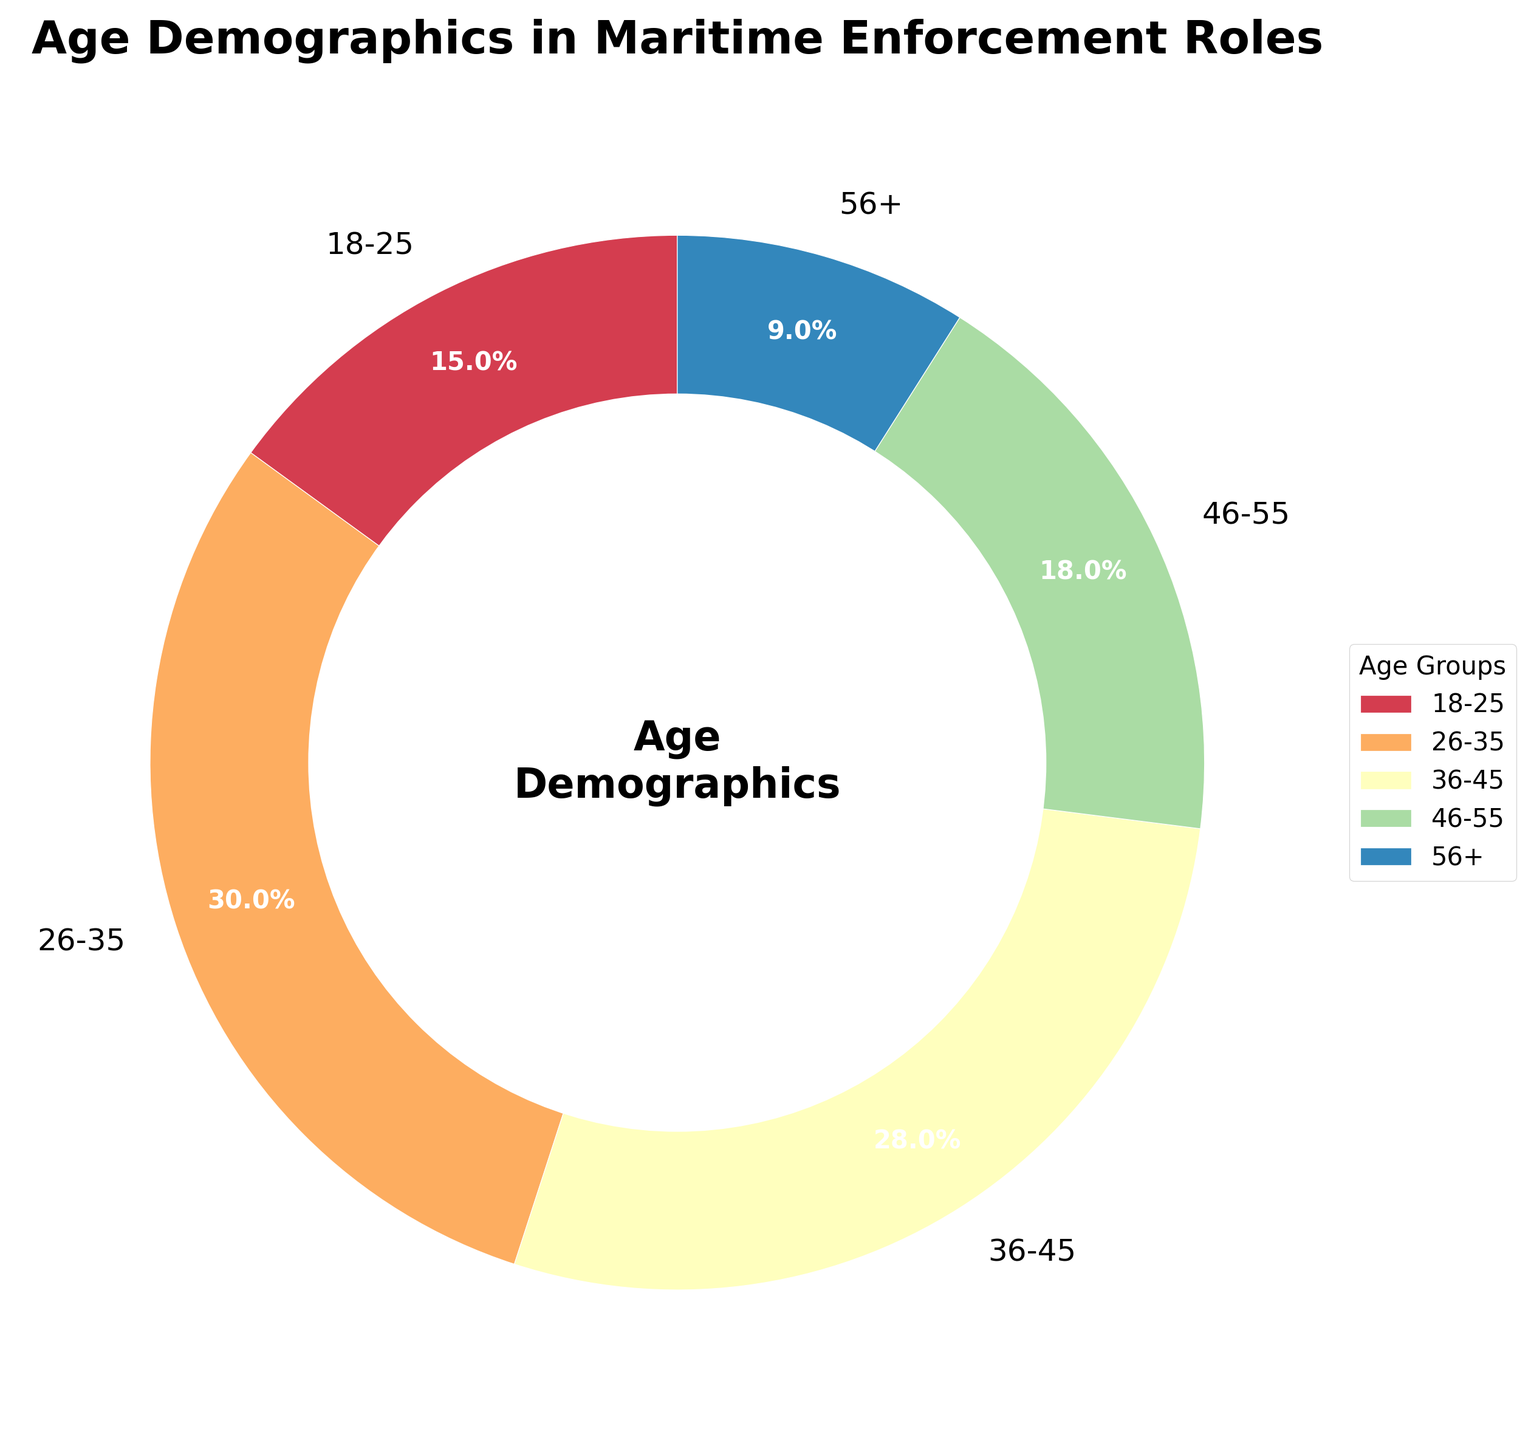What percentage of personnel are aged 26-35? Look at the pie chart slice labeled '26-35' and read the percentage value displayed.
Answer: 30% Which age group has the smallest representation in maritime enforcement roles? Identify the slice with the smallest percentage. The '56+' age group has the smallest slice.
Answer: 56+ What is the total percentage of personnel aged 36-55? Add the percentages of the '36-45' and '46-55' age groups: 28% + 18%.
Answer: 46% How do the percentages of the '18-25' and '56+' age groups compare? Compare the slices labeled '18-25' (15%) and '56+' (9%) by looking at their size and percentage values.
Answer: '18-25' is greater Which age group's slice is just slightly smaller than the 26-35 age group's slice? Identify the slice sizes and find the one closest but smaller than '26-35' (30%), which is '36-45' (28%).
Answer: '36-45' What is the difference in percentage between the '46-55' and '18-25' age groups? Subtract the percentage of '18-25' (15%) from '46-55' (18%): 18% - 15%.
Answer: 3% Are there more personnel aged 26-35 or in the combined groups of '46-55' and '56+'? Add the percentages of '46-55' and '56+' and compare to '26-35'. '46-55' (18%) + '56+' (9%) = 27%, which is less than '26-35' (30%).
Answer: 26-35 Which age group occupies the second-largest slice in the chart? Observe the pie chart and determine which slice is the second largest after '26-35' (30%), which is '36-45' (28%).
Answer: '36-45' How would you visually describe the color of the '56+' age group slice? Identify the '56+' pie slice and describe the dominant color it is filled with.
Answer: Light reddish-orange What visual feature is used to the highlight significance of the "Age Demographics" in the center of the pie chart? Observe the center of the pie chart, see the white circle enclosing the text "Age Demographics" used to emphasize it.
Answer: White circle 